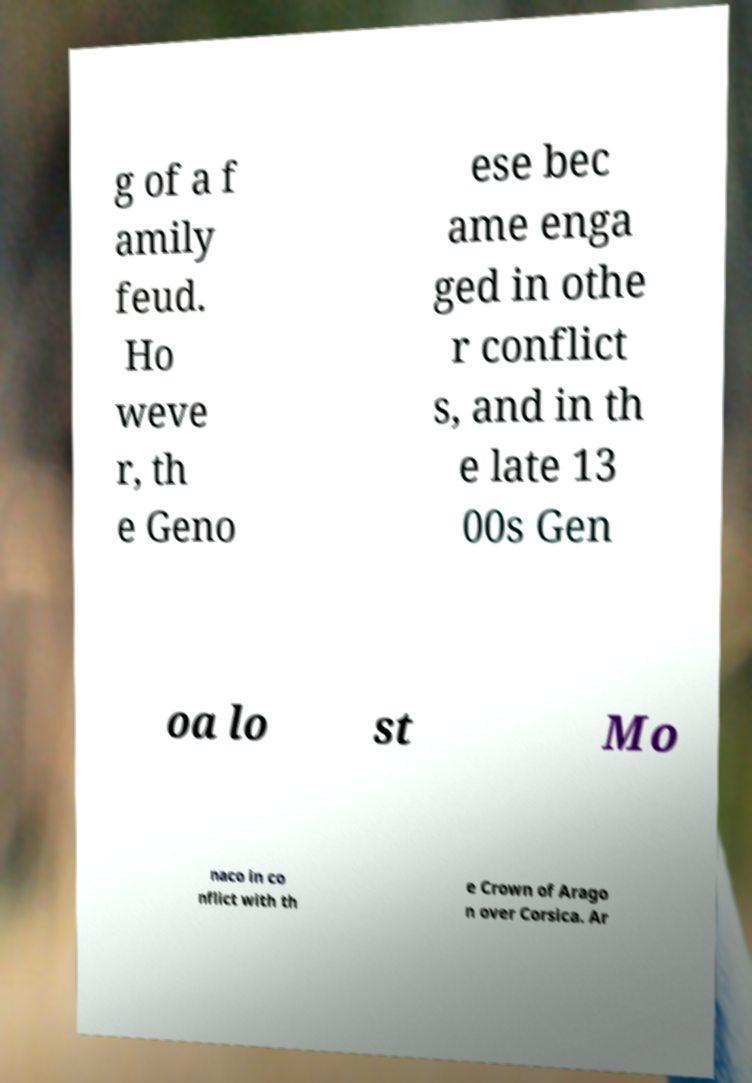There's text embedded in this image that I need extracted. Can you transcribe it verbatim? g of a f amily feud. Ho weve r, th e Geno ese bec ame enga ged in othe r conflict s, and in th e late 13 00s Gen oa lo st Mo naco in co nflict with th e Crown of Arago n over Corsica. Ar 